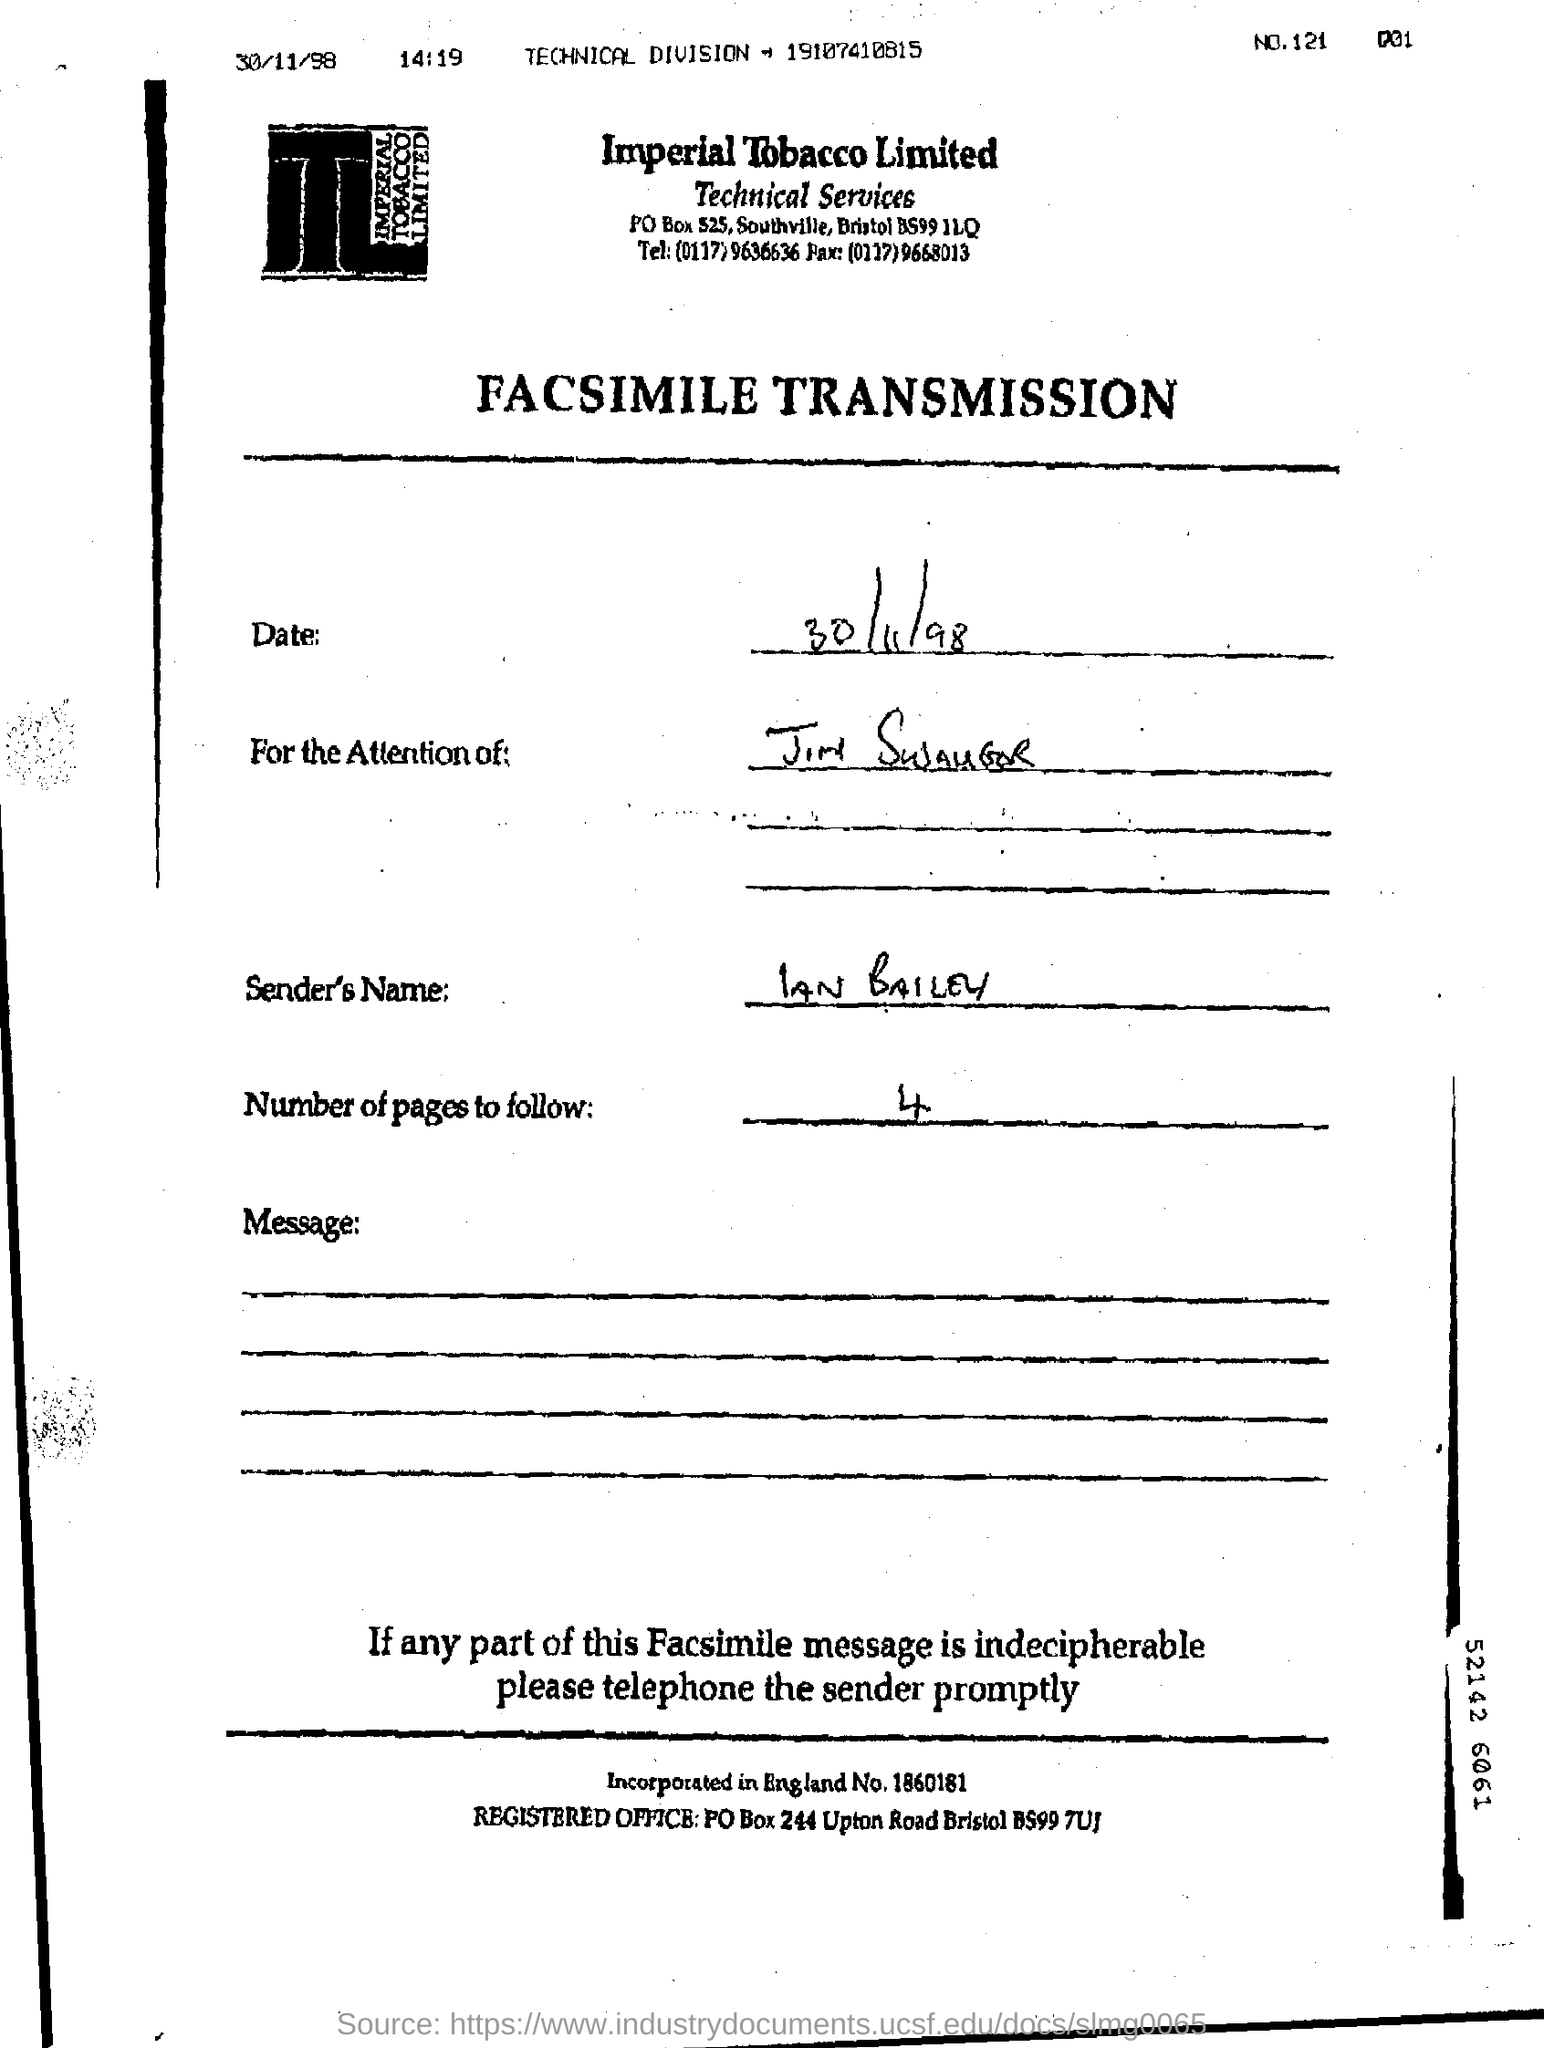Which company's name is at the top of the page?
Your answer should be very brief. Imperial Tobacco Limited. What type of document is this?
Provide a short and direct response. FACSIMILE TRANSMISSION. What date is given?
Make the answer very short. 30/11/98. What is the sender's name?
Make the answer very short. IAN BAILEY. How many pages are to follow?
Keep it short and to the point. 4. 